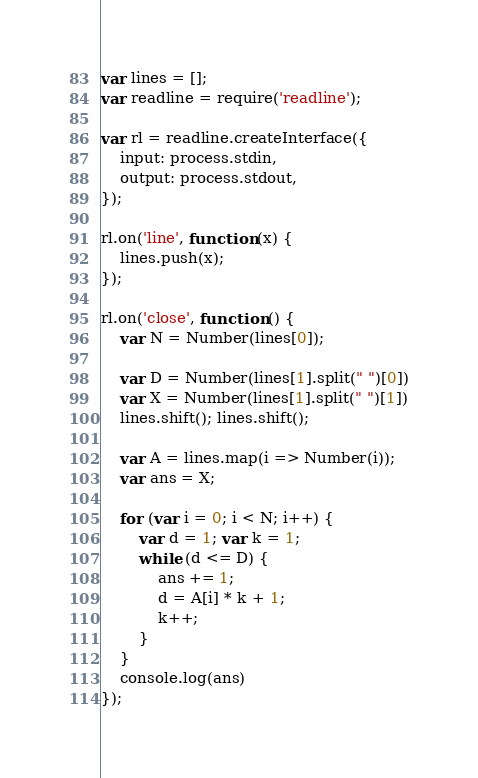<code> <loc_0><loc_0><loc_500><loc_500><_JavaScript_>var lines = [];
var readline = require('readline');

var rl = readline.createInterface({
    input: process.stdin,
    output: process.stdout,
});

rl.on('line', function (x) {
    lines.push(x);
});

rl.on('close', function () {
    var N = Number(lines[0]);

    var D = Number(lines[1].split(" ")[0])
    var X = Number(lines[1].split(" ")[1])
    lines.shift(); lines.shift();

    var A = lines.map(i => Number(i));
    var ans = X;

    for (var i = 0; i < N; i++) {
        var d = 1; var k = 1;
        while (d <= D) {
            ans += 1;
            d = A[i] * k + 1;
            k++;
        }
    }
    console.log(ans)
});</code> 